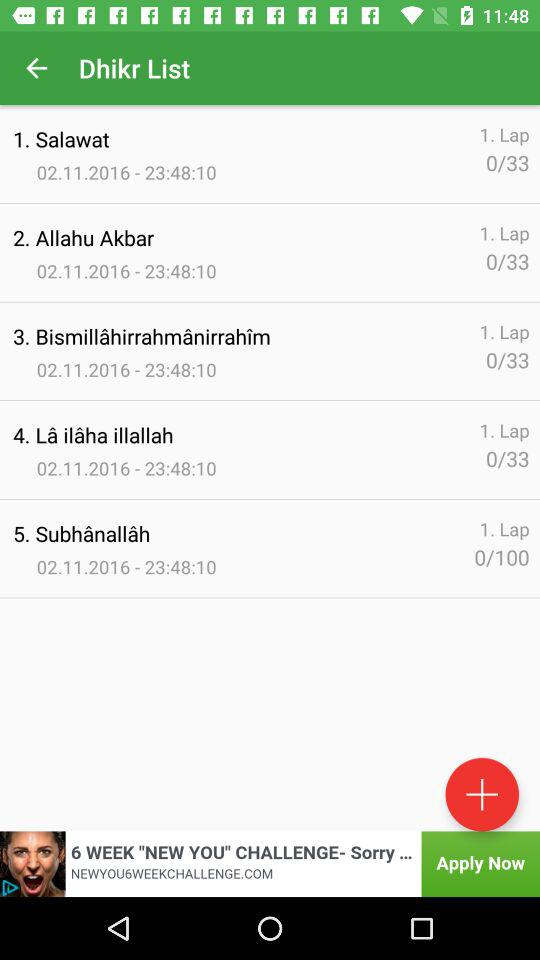How many Dhikrs are there in total?
Answer the question using a single word or phrase. 5 